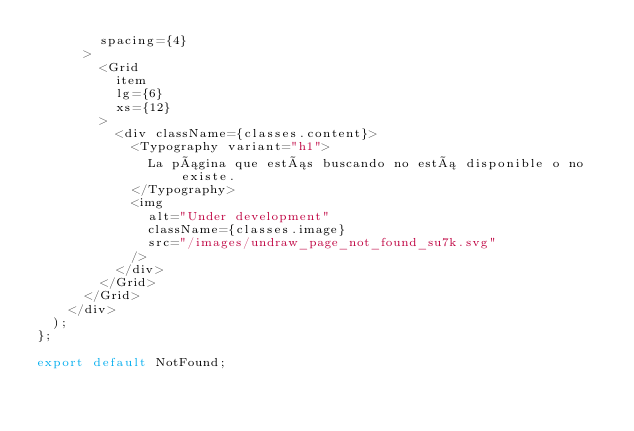<code> <loc_0><loc_0><loc_500><loc_500><_JavaScript_>        spacing={4}
      >
        <Grid
          item
          lg={6}
          xs={12}
        >
          <div className={classes.content}>
            <Typography variant="h1">
              La página que estás buscando no está disponible o no existe.
            </Typography>
            <img
              alt="Under development"
              className={classes.image}
              src="/images/undraw_page_not_found_su7k.svg"
            />
          </div>
        </Grid>
      </Grid>
    </div>
  );
};

export default NotFound;
</code> 